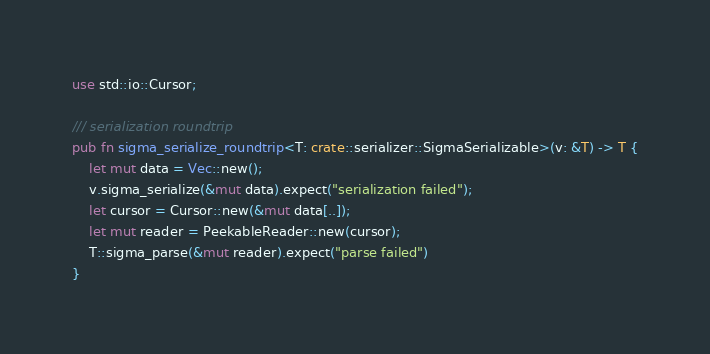<code> <loc_0><loc_0><loc_500><loc_500><_Rust_>use std::io::Cursor;

/// serialization roundtrip
pub fn sigma_serialize_roundtrip<T: crate::serializer::SigmaSerializable>(v: &T) -> T {
    let mut data = Vec::new();
    v.sigma_serialize(&mut data).expect("serialization failed");
    let cursor = Cursor::new(&mut data[..]);
    let mut reader = PeekableReader::new(cursor);
    T::sigma_parse(&mut reader).expect("parse failed")
}
</code> 